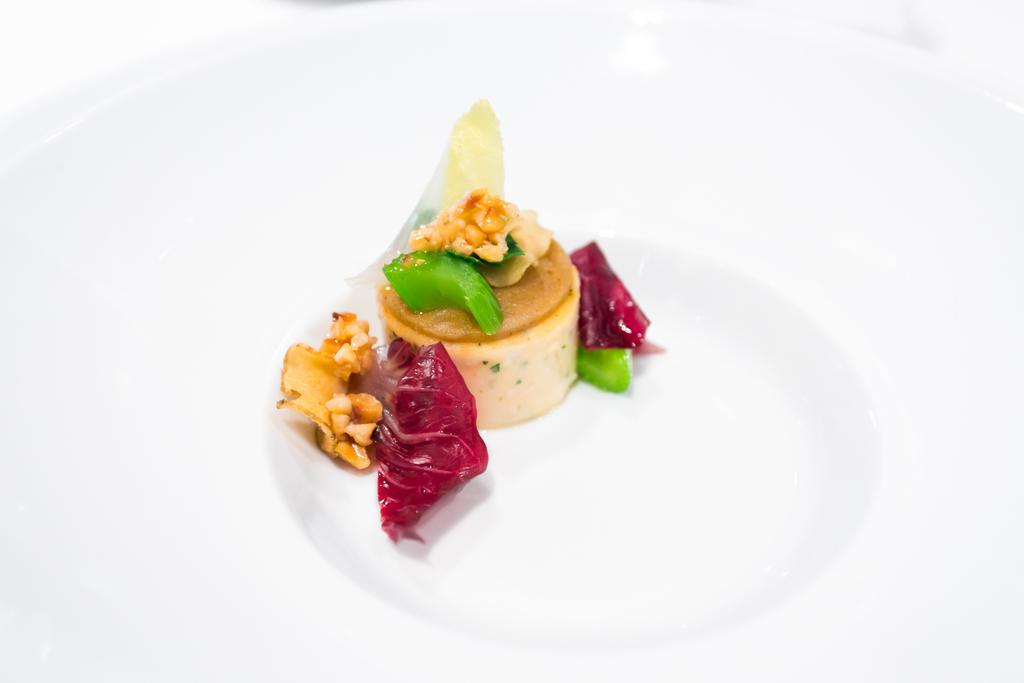What is on the plate that is visible in the image? There is food on a plate in the image. Where is the plate located in the image? The plate is placed on a surface in the image. What substance is being smashed in the image? There is no substance being smashed in the image; it only shows food on a plate placed on a surface. 